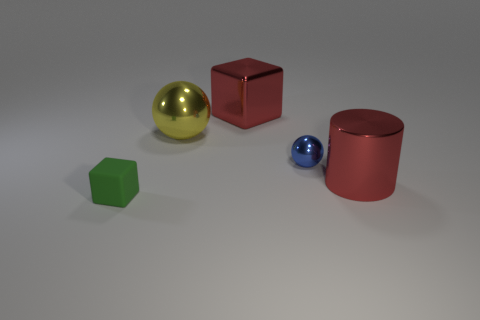Is there anything else that has the same material as the tiny green thing?
Your answer should be compact. No. Is there anything else that is the same color as the shiny cylinder?
Make the answer very short. Yes. What number of things are either small red things or metallic spheres that are to the right of the big metallic cube?
Offer a very short reply. 1. What material is the object in front of the red metallic thing on the right side of the cube to the right of the tiny matte object made of?
Offer a terse response. Rubber. There is a red block that is the same material as the red cylinder; what size is it?
Your answer should be very brief. Large. There is a cube that is right of the block in front of the red metallic cube; what is its color?
Offer a very short reply. Red. How many small green blocks are made of the same material as the blue sphere?
Ensure brevity in your answer.  0. What number of metal things are either brown blocks or big things?
Keep it short and to the point. 3. What is the material of the block that is the same size as the blue metallic sphere?
Give a very brief answer. Rubber. Are there any yellow balls made of the same material as the blue object?
Make the answer very short. Yes. 